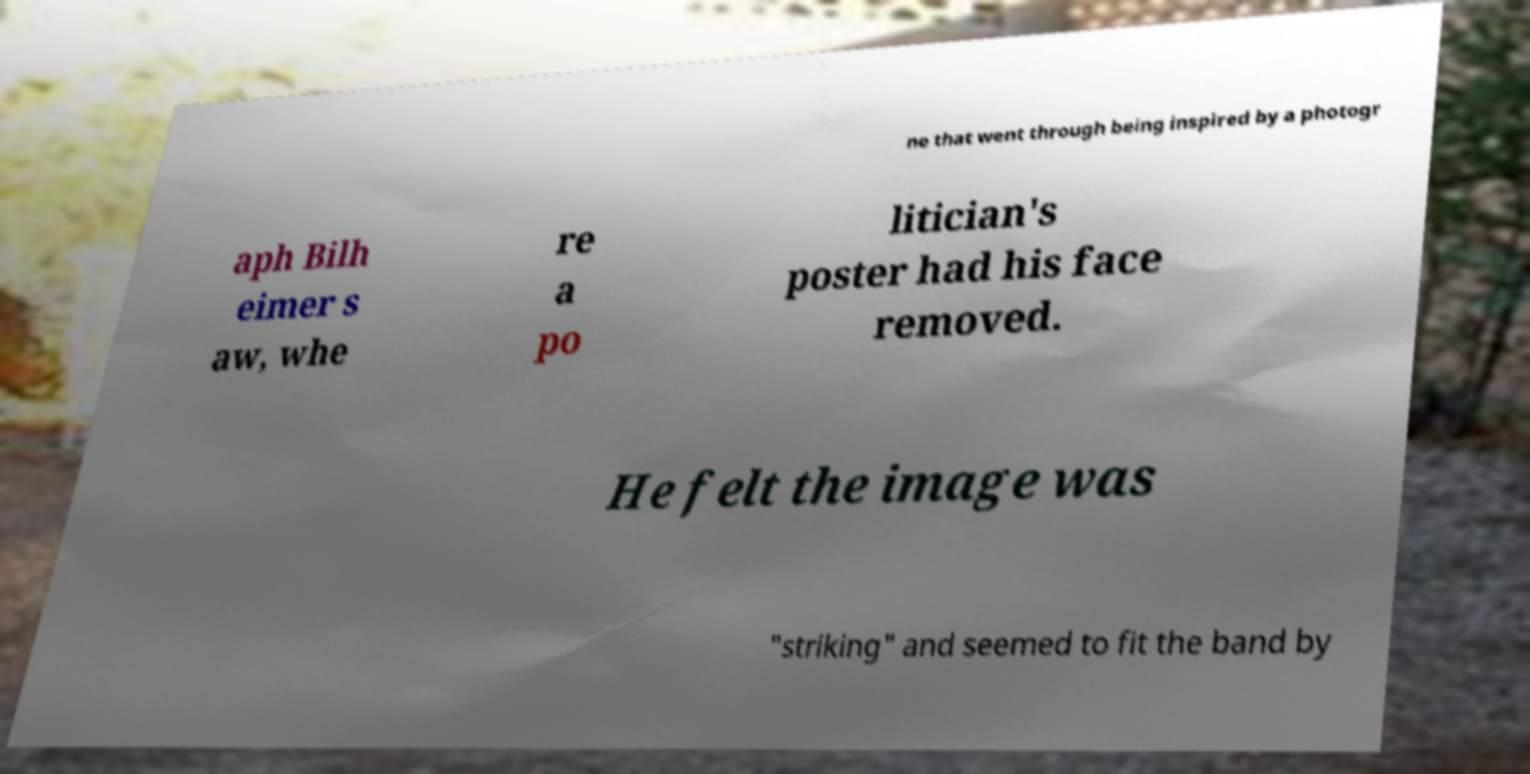Can you accurately transcribe the text from the provided image for me? ne that went through being inspired by a photogr aph Bilh eimer s aw, whe re a po litician's poster had his face removed. He felt the image was "striking" and seemed to fit the band by 